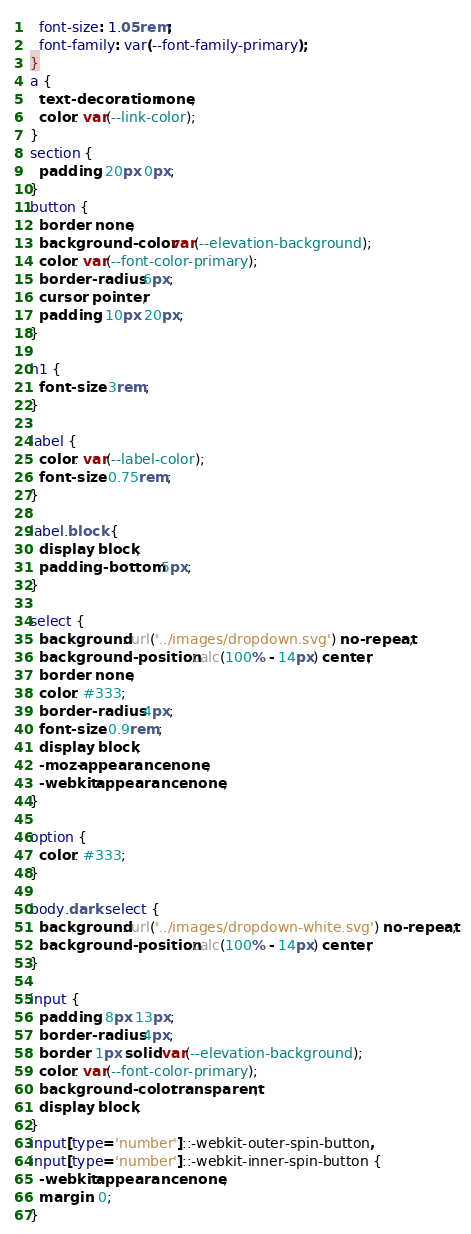<code> <loc_0><loc_0><loc_500><loc_500><_CSS_>  font-size: 1.05rem;
  font-family: var(--font-family-primary);
}
a {
  text-decoration: none;
  color: var(--link-color);
}
section {
  padding: 20px 0px;
}
button {
  border: none;
  background-color: var(--elevation-background);
  color: var(--font-color-primary);
  border-radius: 6px;
  cursor: pointer;
  padding: 10px 20px;
}

h1 {
  font-size: 3rem;
}

label {
  color: var(--label-color);
  font-size: 0.75rem;
}

label.block {
  display: block;
  padding-bottom: 5px;
}

select {
  background: url('../images/dropdown.svg') no-repeat;
  background-position: calc(100% - 14px) center;
  border: none;
  color: #333;
  border-radius: 4px;
  font-size: 0.9rem;
  display: block;
  -moz-appearance: none;
  -webkit-appearance: none;
}

option {
  color: #333;
}

body.dark select {
  background: url('../images/dropdown-white.svg') no-repeat;
  background-position: calc(100% - 14px) center;
}

input {
  padding: 8px 13px;
  border-radius: 4px;
  border: 1px solid var(--elevation-background);
  color: var(--font-color-primary);
  background-color: transparent;
  display: block;
}
input[type='number']::-webkit-outer-spin-button,
input[type='number']::-webkit-inner-spin-button {
  -webkit-appearance: none;
  margin: 0;
}</code> 